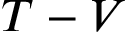Convert formula to latex. <formula><loc_0><loc_0><loc_500><loc_500>T - V</formula> 